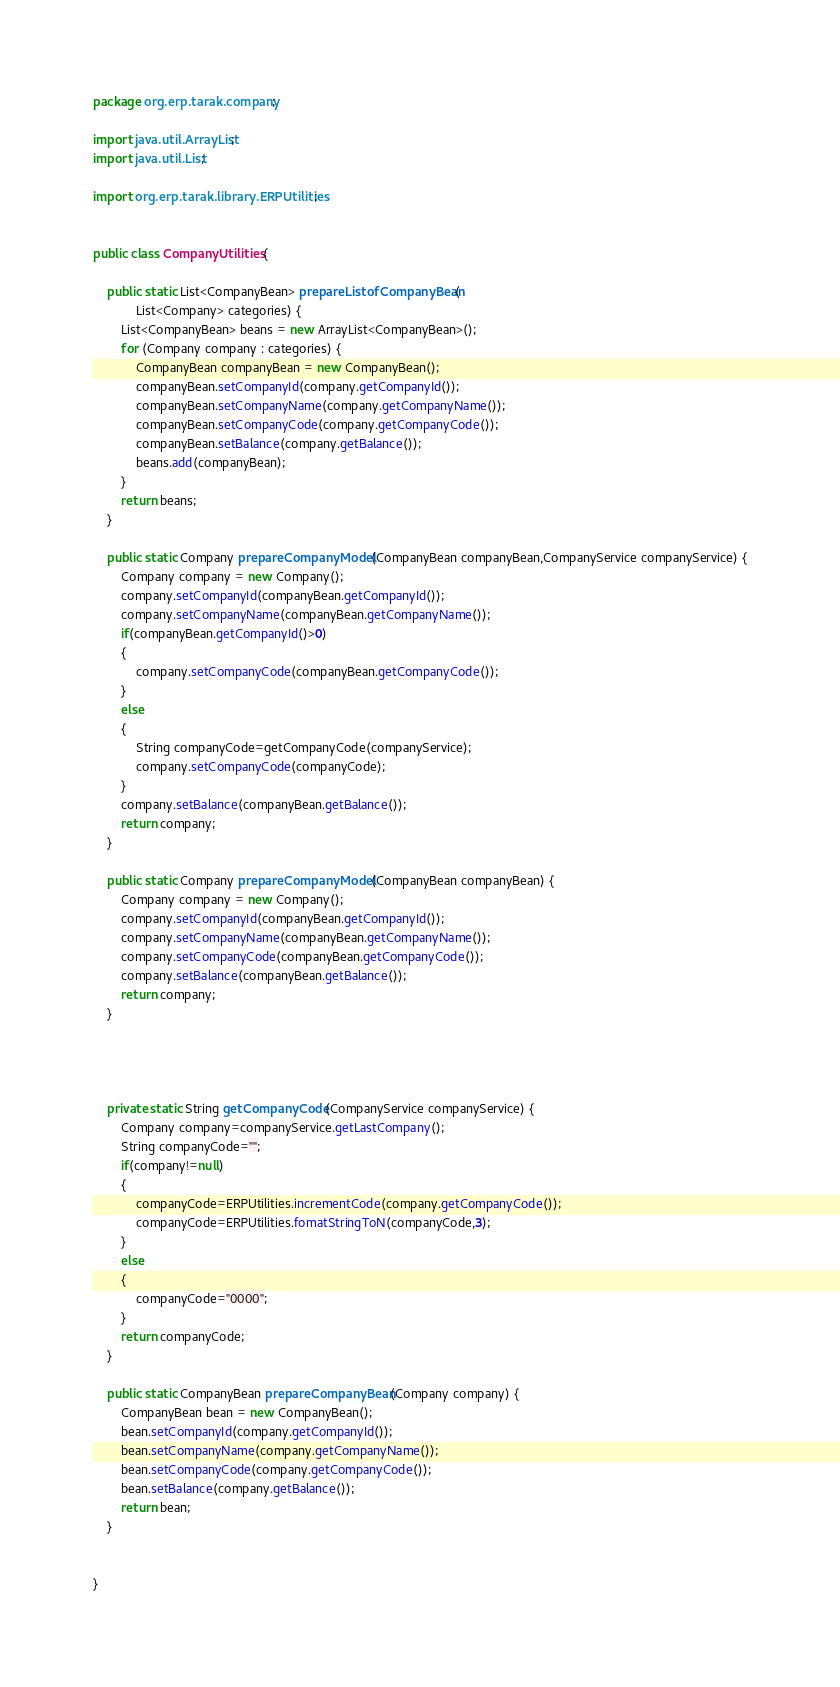<code> <loc_0><loc_0><loc_500><loc_500><_Java_>package org.erp.tarak.company;

import java.util.ArrayList;
import java.util.List;

import org.erp.tarak.library.ERPUtilities;


public class CompanyUtilities {

	public static List<CompanyBean> prepareListofCompanyBean(
			List<Company> categories) {
		List<CompanyBean> beans = new ArrayList<CompanyBean>();
		for (Company company : categories) {
			CompanyBean companyBean = new CompanyBean();
			companyBean.setCompanyId(company.getCompanyId());
			companyBean.setCompanyName(company.getCompanyName());
			companyBean.setCompanyCode(company.getCompanyCode());
			companyBean.setBalance(company.getBalance());
			beans.add(companyBean);
		}
		return beans;
	}

	public static Company prepareCompanyModel(CompanyBean companyBean,CompanyService companyService) {
		Company company = new Company();
		company.setCompanyId(companyBean.getCompanyId());
		company.setCompanyName(companyBean.getCompanyName());
		if(companyBean.getCompanyId()>0)
		{
			company.setCompanyCode(companyBean.getCompanyCode());
		}
		else
		{
			String companyCode=getCompanyCode(companyService);
			company.setCompanyCode(companyCode);
		}
		company.setBalance(companyBean.getBalance());
		return company;
	}

	public static Company prepareCompanyModel(CompanyBean companyBean) {
		Company company = new Company();
		company.setCompanyId(companyBean.getCompanyId());
		company.setCompanyName(companyBean.getCompanyName());
		company.setCompanyCode(companyBean.getCompanyCode());
		company.setBalance(companyBean.getBalance());
		return company;
	}

	
	
	
	private static String getCompanyCode(CompanyService companyService) {
		Company company=companyService.getLastCompany();
		String companyCode="";
		if(company!=null)
		{
			companyCode=ERPUtilities.incrementCode(company.getCompanyCode());
			companyCode=ERPUtilities.fomatStringToN(companyCode,3);
		}
		else
		{
			companyCode="0000";
		}
		return companyCode;
	}

	public static CompanyBean prepareCompanyBean(Company company) {
		CompanyBean bean = new CompanyBean();
		bean.setCompanyId(company.getCompanyId());
		bean.setCompanyName(company.getCompanyName());
		bean.setCompanyCode(company.getCompanyCode());
		bean.setBalance(company.getBalance());
		return bean;
	}


}
</code> 